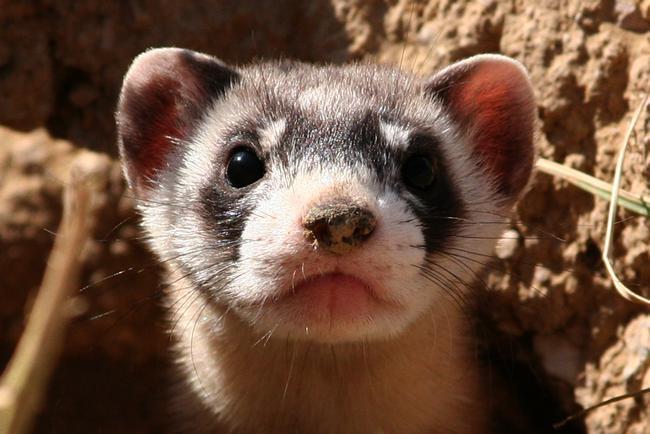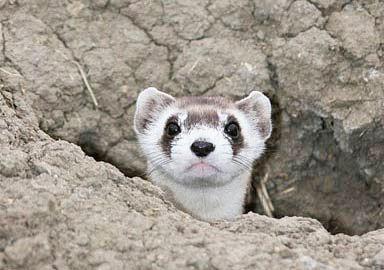The first image is the image on the left, the second image is the image on the right. For the images shown, is this caption "The right image contains a ferret sticking their head out of a dirt hole." true? Answer yes or no. Yes. The first image is the image on the left, the second image is the image on the right. Assess this claim about the two images: "Each image shows a single ferret with its head emerging from a hole in the dirt.". Correct or not? Answer yes or no. Yes. 